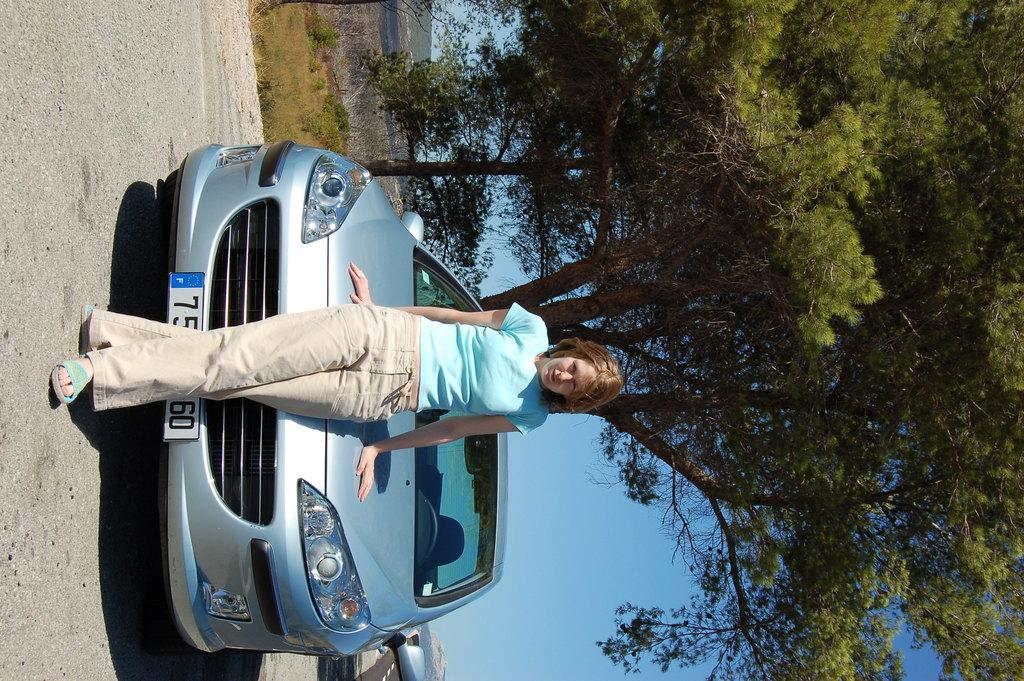How is the orientation of the image? The image is rotated. Who is present in the image? There is a lady in the image. What is the lady wearing? The lady is wearing a blue t-shirt. What is behind the lady in the image? There are trees, hills, and a road in the background of the image. What is the condition of the sky in the image? The sky is clear in the image. Can you hear the lady whistling in the image? There is no indication of sound in the image, so it cannot be determined if the lady is whistling or not. Is there any lettuce visible in the image? There is no lettuce present in the image. 